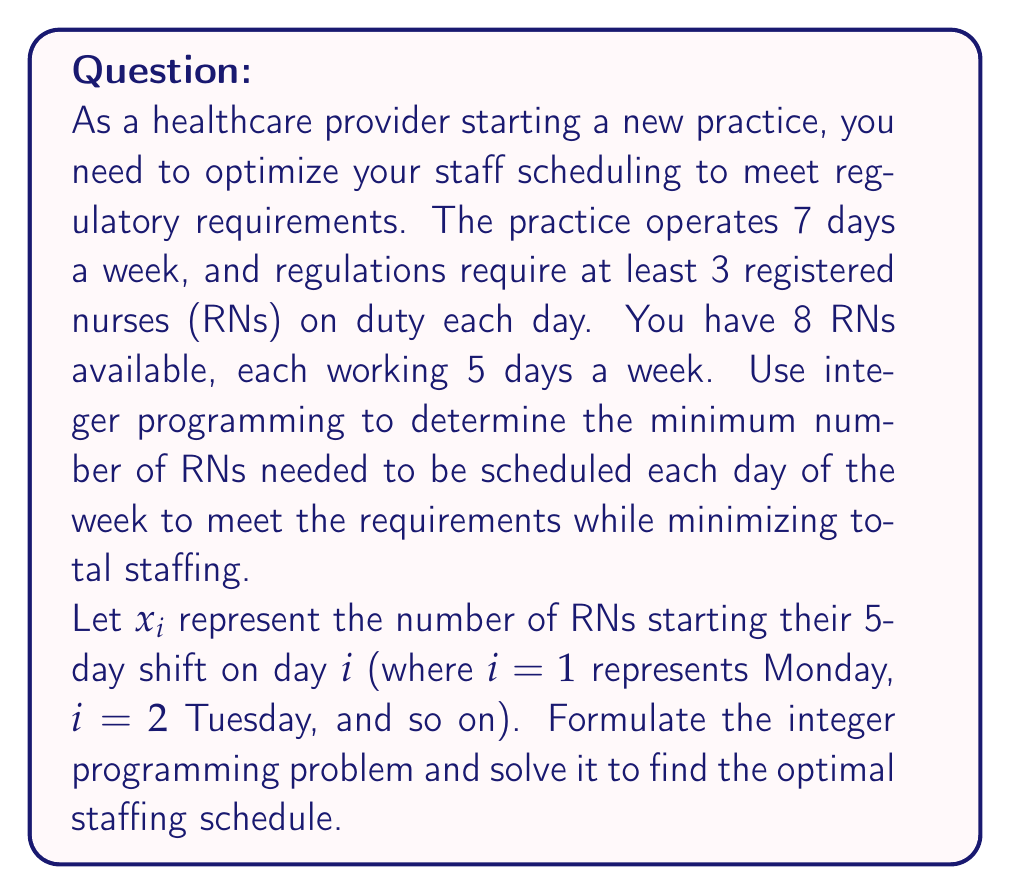Can you solve this math problem? To solve this problem, we need to formulate an integer programming model:

1. Decision variables:
   $x_i$ = number of RNs starting their 5-day shift on day $i$ (integer)

2. Objective function:
   Minimize total staffing: $\min Z = \sum_{i=1}^7 x_i$

3. Constraints:
   a) For each day, ensure at least 3 RNs are working:
      $$x_i + x_{i-1} + x_{i-2} + x_{i-3} + x_{i-4} \geq 3 \text{ for } i = 1,2,\ldots,7$$
      (Note: Indices wrap around, so $x_0 = x_7$, $x_{-1} = x_6$, etc.)
   
   b) Non-negativity and integer constraints:
      $$x_i \geq 0 \text{ and integer for } i = 1,2,\ldots,7$$

Now, let's solve this integer programming problem:

1. Start with a feasible solution: Schedule 3 RNs every day.
   $x_1 = x_2 = x_3 = x_4 = x_5 = x_6 = x_7 = 3$
   This satisfies all constraints but is not optimal.

2. Observe that we can reduce some variables:
   - Set $x_1 = x_2 = x_3 = 1$ (Monday, Tuesday, Wednesday)
   - Set $x_4 = x_5 = 2$ (Thursday, Friday)
   - Set $x_6 = x_7 = 0$ (Saturday, Sunday)

3. Verify that this solution satisfies all constraints:
   - Monday: $1 + 0 + 0 + 2 + 1 = 4 \geq 3$
   - Tuesday: $1 + 1 + 0 + 0 + 2 = 4 \geq 3$
   - Wednesday: $1 + 1 + 1 + 0 + 0 = 3 \geq 3$
   - Thursday: $2 + 1 + 1 + 1 + 0 = 5 \geq 3$
   - Friday: $2 + 2 + 1 + 1 + 1 = 7 \geq 3$
   - Saturday: $0 + 2 + 2 + 1 + 1 = 6 \geq 3$
   - Sunday: $0 + 0 + 2 + 2 + 1 = 5 \geq 3$

4. Calculate the objective function value:
   $Z = 1 + 1 + 1 + 2 + 2 + 0 + 0 = 7$

This solution is optimal because:
a) It satisfies all constraints.
b) We cannot reduce any $x_i$ without violating a constraint.
c) The total number of RNs scheduled (7) matches the minimum required to cover 7 days with at least 3 RNs per day.
Answer: The optimal staffing schedule is:
- Monday: 1 RN starts shift
- Tuesday: 1 RN starts shift
- Wednesday: 1 RN starts shift
- Thursday: 2 RNs start shift
- Friday: 2 RNs start shift
- Saturday: 0 RNs start shift
- Sunday: 0 RNs start shift

Total RNs needed: 7 